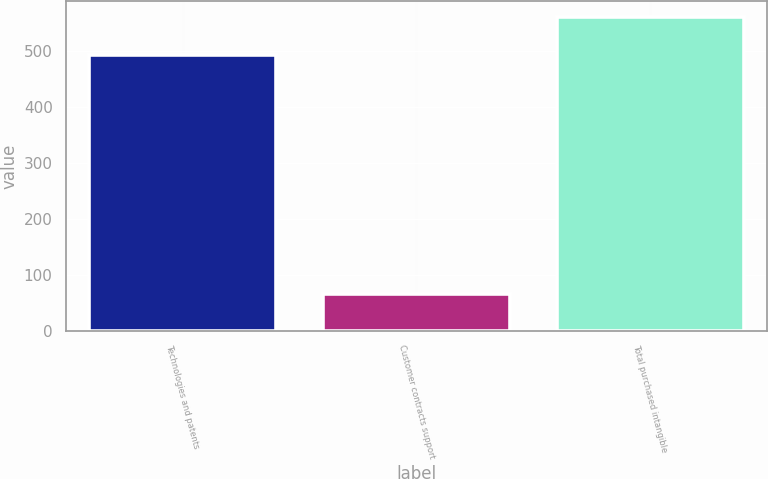<chart> <loc_0><loc_0><loc_500><loc_500><bar_chart><fcel>Technologies and patents<fcel>Customer contracts support<fcel>Total purchased intangible<nl><fcel>491.8<fcel>65.2<fcel>560.3<nl></chart> 